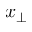<formula> <loc_0><loc_0><loc_500><loc_500>x _ { \perp }</formula> 